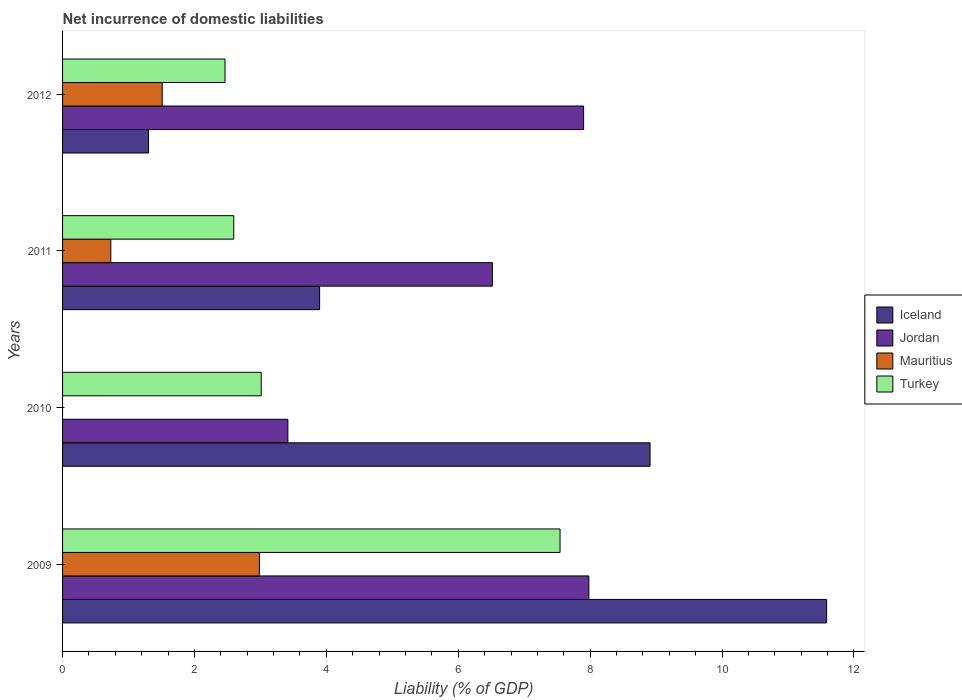How many different coloured bars are there?
Make the answer very short. 4. Are the number of bars on each tick of the Y-axis equal?
Your response must be concise. No. How many bars are there on the 2nd tick from the top?
Offer a very short reply. 4. What is the label of the 2nd group of bars from the top?
Make the answer very short. 2011. In how many cases, is the number of bars for a given year not equal to the number of legend labels?
Your answer should be very brief. 1. What is the net incurrence of domestic liabilities in Jordan in 2012?
Provide a short and direct response. 7.9. Across all years, what is the maximum net incurrence of domestic liabilities in Jordan?
Provide a succinct answer. 7.98. Across all years, what is the minimum net incurrence of domestic liabilities in Jordan?
Ensure brevity in your answer.  3.42. In which year was the net incurrence of domestic liabilities in Mauritius maximum?
Your response must be concise. 2009. What is the total net incurrence of domestic liabilities in Turkey in the graph?
Provide a succinct answer. 15.61. What is the difference between the net incurrence of domestic liabilities in Iceland in 2009 and that in 2011?
Your response must be concise. 7.69. What is the difference between the net incurrence of domestic liabilities in Jordan in 2010 and the net incurrence of domestic liabilities in Iceland in 2012?
Your answer should be compact. 2.11. What is the average net incurrence of domestic liabilities in Iceland per year?
Give a very brief answer. 6.42. In the year 2011, what is the difference between the net incurrence of domestic liabilities in Mauritius and net incurrence of domestic liabilities in Iceland?
Offer a very short reply. -3.17. What is the ratio of the net incurrence of domestic liabilities in Iceland in 2009 to that in 2012?
Ensure brevity in your answer.  8.89. Is the net incurrence of domestic liabilities in Turkey in 2010 less than that in 2011?
Offer a terse response. No. What is the difference between the highest and the second highest net incurrence of domestic liabilities in Iceland?
Give a very brief answer. 2.68. What is the difference between the highest and the lowest net incurrence of domestic liabilities in Turkey?
Offer a very short reply. 5.08. In how many years, is the net incurrence of domestic liabilities in Jordan greater than the average net incurrence of domestic liabilities in Jordan taken over all years?
Make the answer very short. 3. Is the sum of the net incurrence of domestic liabilities in Jordan in 2010 and 2011 greater than the maximum net incurrence of domestic liabilities in Turkey across all years?
Give a very brief answer. Yes. How many bars are there?
Provide a succinct answer. 15. How many years are there in the graph?
Provide a short and direct response. 4. Does the graph contain grids?
Offer a very short reply. No. How are the legend labels stacked?
Your answer should be compact. Vertical. What is the title of the graph?
Your response must be concise. Net incurrence of domestic liabilities. Does "Armenia" appear as one of the legend labels in the graph?
Keep it short and to the point. No. What is the label or title of the X-axis?
Provide a short and direct response. Liability (% of GDP). What is the label or title of the Y-axis?
Provide a short and direct response. Years. What is the Liability (% of GDP) in Iceland in 2009?
Your answer should be compact. 11.59. What is the Liability (% of GDP) of Jordan in 2009?
Your response must be concise. 7.98. What is the Liability (% of GDP) of Mauritius in 2009?
Your answer should be very brief. 2.98. What is the Liability (% of GDP) in Turkey in 2009?
Keep it short and to the point. 7.54. What is the Liability (% of GDP) in Iceland in 2010?
Provide a short and direct response. 8.91. What is the Liability (% of GDP) in Jordan in 2010?
Provide a short and direct response. 3.42. What is the Liability (% of GDP) in Turkey in 2010?
Keep it short and to the point. 3.01. What is the Liability (% of GDP) of Iceland in 2011?
Provide a succinct answer. 3.9. What is the Liability (% of GDP) in Jordan in 2011?
Offer a very short reply. 6.52. What is the Liability (% of GDP) of Mauritius in 2011?
Your response must be concise. 0.73. What is the Liability (% of GDP) in Turkey in 2011?
Provide a short and direct response. 2.6. What is the Liability (% of GDP) of Iceland in 2012?
Provide a succinct answer. 1.3. What is the Liability (% of GDP) in Jordan in 2012?
Provide a succinct answer. 7.9. What is the Liability (% of GDP) in Mauritius in 2012?
Give a very brief answer. 1.51. What is the Liability (% of GDP) in Turkey in 2012?
Offer a very short reply. 2.46. Across all years, what is the maximum Liability (% of GDP) in Iceland?
Ensure brevity in your answer.  11.59. Across all years, what is the maximum Liability (% of GDP) of Jordan?
Provide a short and direct response. 7.98. Across all years, what is the maximum Liability (% of GDP) in Mauritius?
Offer a terse response. 2.98. Across all years, what is the maximum Liability (% of GDP) of Turkey?
Keep it short and to the point. 7.54. Across all years, what is the minimum Liability (% of GDP) of Iceland?
Your answer should be compact. 1.3. Across all years, what is the minimum Liability (% of GDP) in Jordan?
Provide a succinct answer. 3.42. Across all years, what is the minimum Liability (% of GDP) in Turkey?
Give a very brief answer. 2.46. What is the total Liability (% of GDP) in Iceland in the graph?
Give a very brief answer. 25.7. What is the total Liability (% of GDP) of Jordan in the graph?
Give a very brief answer. 25.82. What is the total Liability (% of GDP) in Mauritius in the graph?
Provide a succinct answer. 5.23. What is the total Liability (% of GDP) in Turkey in the graph?
Ensure brevity in your answer.  15.62. What is the difference between the Liability (% of GDP) in Iceland in 2009 and that in 2010?
Keep it short and to the point. 2.68. What is the difference between the Liability (% of GDP) in Jordan in 2009 and that in 2010?
Provide a short and direct response. 4.56. What is the difference between the Liability (% of GDP) in Turkey in 2009 and that in 2010?
Provide a succinct answer. 4.53. What is the difference between the Liability (% of GDP) of Iceland in 2009 and that in 2011?
Offer a terse response. 7.69. What is the difference between the Liability (% of GDP) of Jordan in 2009 and that in 2011?
Provide a short and direct response. 1.46. What is the difference between the Liability (% of GDP) in Mauritius in 2009 and that in 2011?
Keep it short and to the point. 2.25. What is the difference between the Liability (% of GDP) of Turkey in 2009 and that in 2011?
Your answer should be very brief. 4.95. What is the difference between the Liability (% of GDP) of Iceland in 2009 and that in 2012?
Give a very brief answer. 10.28. What is the difference between the Liability (% of GDP) of Jordan in 2009 and that in 2012?
Your answer should be compact. 0.08. What is the difference between the Liability (% of GDP) of Mauritius in 2009 and that in 2012?
Give a very brief answer. 1.47. What is the difference between the Liability (% of GDP) in Turkey in 2009 and that in 2012?
Provide a succinct answer. 5.08. What is the difference between the Liability (% of GDP) in Iceland in 2010 and that in 2011?
Provide a short and direct response. 5.01. What is the difference between the Liability (% of GDP) in Jordan in 2010 and that in 2011?
Give a very brief answer. -3.1. What is the difference between the Liability (% of GDP) of Turkey in 2010 and that in 2011?
Make the answer very short. 0.42. What is the difference between the Liability (% of GDP) in Iceland in 2010 and that in 2012?
Provide a short and direct response. 7.6. What is the difference between the Liability (% of GDP) of Jordan in 2010 and that in 2012?
Ensure brevity in your answer.  -4.48. What is the difference between the Liability (% of GDP) of Turkey in 2010 and that in 2012?
Keep it short and to the point. 0.55. What is the difference between the Liability (% of GDP) in Iceland in 2011 and that in 2012?
Offer a terse response. 2.59. What is the difference between the Liability (% of GDP) of Jordan in 2011 and that in 2012?
Offer a very short reply. -1.38. What is the difference between the Liability (% of GDP) of Mauritius in 2011 and that in 2012?
Offer a terse response. -0.78. What is the difference between the Liability (% of GDP) of Turkey in 2011 and that in 2012?
Your response must be concise. 0.13. What is the difference between the Liability (% of GDP) of Iceland in 2009 and the Liability (% of GDP) of Jordan in 2010?
Provide a short and direct response. 8.17. What is the difference between the Liability (% of GDP) of Iceland in 2009 and the Liability (% of GDP) of Turkey in 2010?
Your answer should be compact. 8.57. What is the difference between the Liability (% of GDP) of Jordan in 2009 and the Liability (% of GDP) of Turkey in 2010?
Provide a succinct answer. 4.97. What is the difference between the Liability (% of GDP) in Mauritius in 2009 and the Liability (% of GDP) in Turkey in 2010?
Your answer should be compact. -0.03. What is the difference between the Liability (% of GDP) in Iceland in 2009 and the Liability (% of GDP) in Jordan in 2011?
Make the answer very short. 5.07. What is the difference between the Liability (% of GDP) of Iceland in 2009 and the Liability (% of GDP) of Mauritius in 2011?
Provide a succinct answer. 10.85. What is the difference between the Liability (% of GDP) of Iceland in 2009 and the Liability (% of GDP) of Turkey in 2011?
Offer a terse response. 8.99. What is the difference between the Liability (% of GDP) of Jordan in 2009 and the Liability (% of GDP) of Mauritius in 2011?
Offer a very short reply. 7.25. What is the difference between the Liability (% of GDP) of Jordan in 2009 and the Liability (% of GDP) of Turkey in 2011?
Provide a succinct answer. 5.38. What is the difference between the Liability (% of GDP) in Mauritius in 2009 and the Liability (% of GDP) in Turkey in 2011?
Give a very brief answer. 0.39. What is the difference between the Liability (% of GDP) of Iceland in 2009 and the Liability (% of GDP) of Jordan in 2012?
Ensure brevity in your answer.  3.68. What is the difference between the Liability (% of GDP) of Iceland in 2009 and the Liability (% of GDP) of Mauritius in 2012?
Provide a succinct answer. 10.08. What is the difference between the Liability (% of GDP) of Iceland in 2009 and the Liability (% of GDP) of Turkey in 2012?
Offer a terse response. 9.12. What is the difference between the Liability (% of GDP) in Jordan in 2009 and the Liability (% of GDP) in Mauritius in 2012?
Give a very brief answer. 6.47. What is the difference between the Liability (% of GDP) of Jordan in 2009 and the Liability (% of GDP) of Turkey in 2012?
Make the answer very short. 5.52. What is the difference between the Liability (% of GDP) of Mauritius in 2009 and the Liability (% of GDP) of Turkey in 2012?
Keep it short and to the point. 0.52. What is the difference between the Liability (% of GDP) in Iceland in 2010 and the Liability (% of GDP) in Jordan in 2011?
Offer a very short reply. 2.39. What is the difference between the Liability (% of GDP) of Iceland in 2010 and the Liability (% of GDP) of Mauritius in 2011?
Your response must be concise. 8.18. What is the difference between the Liability (% of GDP) of Iceland in 2010 and the Liability (% of GDP) of Turkey in 2011?
Your answer should be compact. 6.31. What is the difference between the Liability (% of GDP) in Jordan in 2010 and the Liability (% of GDP) in Mauritius in 2011?
Offer a terse response. 2.68. What is the difference between the Liability (% of GDP) in Jordan in 2010 and the Liability (% of GDP) in Turkey in 2011?
Offer a very short reply. 0.82. What is the difference between the Liability (% of GDP) in Iceland in 2010 and the Liability (% of GDP) in Jordan in 2012?
Your answer should be compact. 1.01. What is the difference between the Liability (% of GDP) in Iceland in 2010 and the Liability (% of GDP) in Mauritius in 2012?
Give a very brief answer. 7.4. What is the difference between the Liability (% of GDP) in Iceland in 2010 and the Liability (% of GDP) in Turkey in 2012?
Provide a succinct answer. 6.45. What is the difference between the Liability (% of GDP) of Jordan in 2010 and the Liability (% of GDP) of Mauritius in 2012?
Your response must be concise. 1.91. What is the difference between the Liability (% of GDP) of Jordan in 2010 and the Liability (% of GDP) of Turkey in 2012?
Offer a very short reply. 0.95. What is the difference between the Liability (% of GDP) in Iceland in 2011 and the Liability (% of GDP) in Jordan in 2012?
Give a very brief answer. -4. What is the difference between the Liability (% of GDP) in Iceland in 2011 and the Liability (% of GDP) in Mauritius in 2012?
Your answer should be compact. 2.39. What is the difference between the Liability (% of GDP) in Iceland in 2011 and the Liability (% of GDP) in Turkey in 2012?
Provide a succinct answer. 1.43. What is the difference between the Liability (% of GDP) in Jordan in 2011 and the Liability (% of GDP) in Mauritius in 2012?
Make the answer very short. 5.01. What is the difference between the Liability (% of GDP) of Jordan in 2011 and the Liability (% of GDP) of Turkey in 2012?
Your answer should be very brief. 4.05. What is the difference between the Liability (% of GDP) in Mauritius in 2011 and the Liability (% of GDP) in Turkey in 2012?
Give a very brief answer. -1.73. What is the average Liability (% of GDP) in Iceland per year?
Your answer should be compact. 6.42. What is the average Liability (% of GDP) of Jordan per year?
Your answer should be very brief. 6.45. What is the average Liability (% of GDP) in Mauritius per year?
Your answer should be compact. 1.31. What is the average Liability (% of GDP) of Turkey per year?
Keep it short and to the point. 3.9. In the year 2009, what is the difference between the Liability (% of GDP) in Iceland and Liability (% of GDP) in Jordan?
Keep it short and to the point. 3.61. In the year 2009, what is the difference between the Liability (% of GDP) of Iceland and Liability (% of GDP) of Mauritius?
Offer a very short reply. 8.6. In the year 2009, what is the difference between the Liability (% of GDP) of Iceland and Liability (% of GDP) of Turkey?
Provide a short and direct response. 4.04. In the year 2009, what is the difference between the Liability (% of GDP) of Jordan and Liability (% of GDP) of Mauritius?
Your answer should be compact. 5. In the year 2009, what is the difference between the Liability (% of GDP) in Jordan and Liability (% of GDP) in Turkey?
Keep it short and to the point. 0.44. In the year 2009, what is the difference between the Liability (% of GDP) in Mauritius and Liability (% of GDP) in Turkey?
Provide a succinct answer. -4.56. In the year 2010, what is the difference between the Liability (% of GDP) in Iceland and Liability (% of GDP) in Jordan?
Offer a very short reply. 5.49. In the year 2010, what is the difference between the Liability (% of GDP) of Iceland and Liability (% of GDP) of Turkey?
Keep it short and to the point. 5.9. In the year 2010, what is the difference between the Liability (% of GDP) in Jordan and Liability (% of GDP) in Turkey?
Your response must be concise. 0.4. In the year 2011, what is the difference between the Liability (% of GDP) of Iceland and Liability (% of GDP) of Jordan?
Make the answer very short. -2.62. In the year 2011, what is the difference between the Liability (% of GDP) of Iceland and Liability (% of GDP) of Mauritius?
Offer a very short reply. 3.17. In the year 2011, what is the difference between the Liability (% of GDP) in Iceland and Liability (% of GDP) in Turkey?
Make the answer very short. 1.3. In the year 2011, what is the difference between the Liability (% of GDP) of Jordan and Liability (% of GDP) of Mauritius?
Provide a succinct answer. 5.79. In the year 2011, what is the difference between the Liability (% of GDP) of Jordan and Liability (% of GDP) of Turkey?
Make the answer very short. 3.92. In the year 2011, what is the difference between the Liability (% of GDP) in Mauritius and Liability (% of GDP) in Turkey?
Make the answer very short. -1.86. In the year 2012, what is the difference between the Liability (% of GDP) of Iceland and Liability (% of GDP) of Jordan?
Offer a very short reply. -6.6. In the year 2012, what is the difference between the Liability (% of GDP) of Iceland and Liability (% of GDP) of Mauritius?
Offer a very short reply. -0.21. In the year 2012, what is the difference between the Liability (% of GDP) in Iceland and Liability (% of GDP) in Turkey?
Give a very brief answer. -1.16. In the year 2012, what is the difference between the Liability (% of GDP) of Jordan and Liability (% of GDP) of Mauritius?
Ensure brevity in your answer.  6.39. In the year 2012, what is the difference between the Liability (% of GDP) of Jordan and Liability (% of GDP) of Turkey?
Offer a terse response. 5.44. In the year 2012, what is the difference between the Liability (% of GDP) of Mauritius and Liability (% of GDP) of Turkey?
Offer a terse response. -0.95. What is the ratio of the Liability (% of GDP) of Iceland in 2009 to that in 2010?
Ensure brevity in your answer.  1.3. What is the ratio of the Liability (% of GDP) in Jordan in 2009 to that in 2010?
Offer a very short reply. 2.34. What is the ratio of the Liability (% of GDP) of Turkey in 2009 to that in 2010?
Ensure brevity in your answer.  2.5. What is the ratio of the Liability (% of GDP) of Iceland in 2009 to that in 2011?
Keep it short and to the point. 2.97. What is the ratio of the Liability (% of GDP) in Jordan in 2009 to that in 2011?
Your response must be concise. 1.22. What is the ratio of the Liability (% of GDP) in Mauritius in 2009 to that in 2011?
Offer a terse response. 4.08. What is the ratio of the Liability (% of GDP) in Turkey in 2009 to that in 2011?
Make the answer very short. 2.91. What is the ratio of the Liability (% of GDP) of Iceland in 2009 to that in 2012?
Your answer should be very brief. 8.89. What is the ratio of the Liability (% of GDP) of Mauritius in 2009 to that in 2012?
Give a very brief answer. 1.98. What is the ratio of the Liability (% of GDP) in Turkey in 2009 to that in 2012?
Make the answer very short. 3.06. What is the ratio of the Liability (% of GDP) of Iceland in 2010 to that in 2011?
Provide a short and direct response. 2.29. What is the ratio of the Liability (% of GDP) of Jordan in 2010 to that in 2011?
Make the answer very short. 0.52. What is the ratio of the Liability (% of GDP) of Turkey in 2010 to that in 2011?
Keep it short and to the point. 1.16. What is the ratio of the Liability (% of GDP) of Iceland in 2010 to that in 2012?
Your answer should be very brief. 6.83. What is the ratio of the Liability (% of GDP) of Jordan in 2010 to that in 2012?
Give a very brief answer. 0.43. What is the ratio of the Liability (% of GDP) in Turkey in 2010 to that in 2012?
Offer a very short reply. 1.22. What is the ratio of the Liability (% of GDP) of Iceland in 2011 to that in 2012?
Provide a succinct answer. 2.99. What is the ratio of the Liability (% of GDP) of Jordan in 2011 to that in 2012?
Ensure brevity in your answer.  0.82. What is the ratio of the Liability (% of GDP) of Mauritius in 2011 to that in 2012?
Offer a terse response. 0.48. What is the ratio of the Liability (% of GDP) in Turkey in 2011 to that in 2012?
Your answer should be very brief. 1.05. What is the difference between the highest and the second highest Liability (% of GDP) of Iceland?
Your answer should be very brief. 2.68. What is the difference between the highest and the second highest Liability (% of GDP) in Jordan?
Make the answer very short. 0.08. What is the difference between the highest and the second highest Liability (% of GDP) of Mauritius?
Your response must be concise. 1.47. What is the difference between the highest and the second highest Liability (% of GDP) of Turkey?
Give a very brief answer. 4.53. What is the difference between the highest and the lowest Liability (% of GDP) in Iceland?
Provide a short and direct response. 10.28. What is the difference between the highest and the lowest Liability (% of GDP) of Jordan?
Keep it short and to the point. 4.56. What is the difference between the highest and the lowest Liability (% of GDP) in Mauritius?
Your response must be concise. 2.98. What is the difference between the highest and the lowest Liability (% of GDP) of Turkey?
Provide a succinct answer. 5.08. 